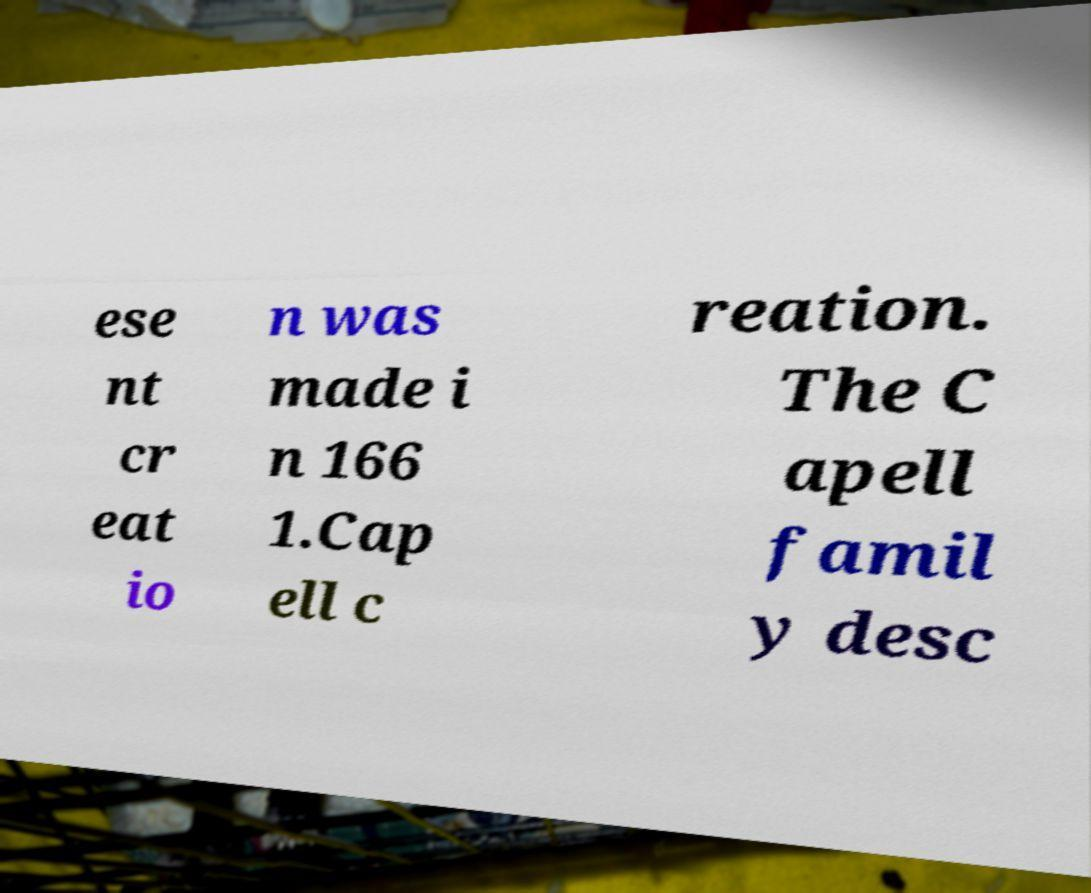I need the written content from this picture converted into text. Can you do that? ese nt cr eat io n was made i n 166 1.Cap ell c reation. The C apell famil y desc 